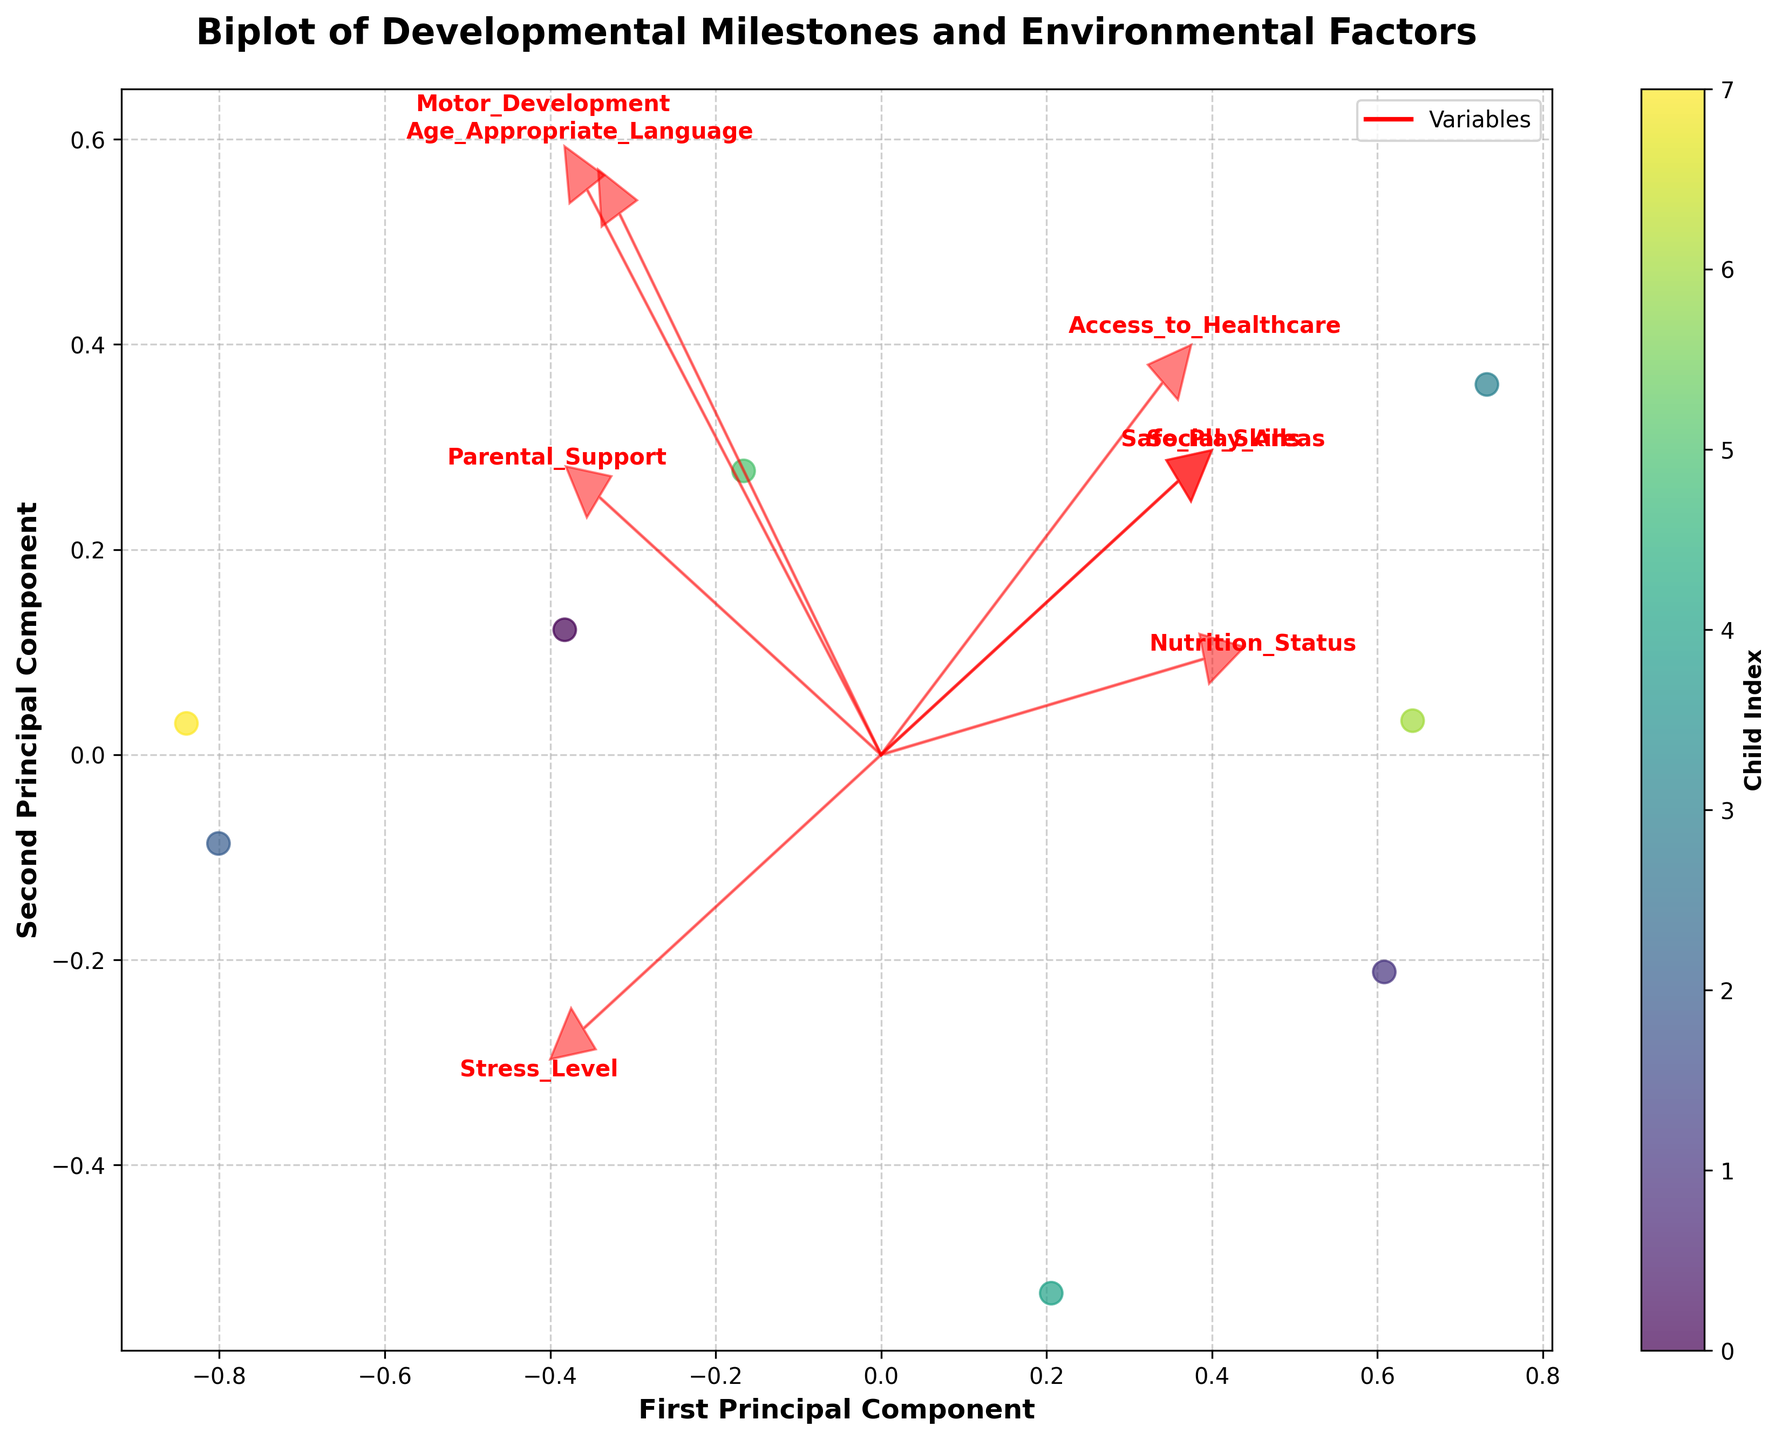What is the title of the plot? The title of the plot is usually displayed at the top of the figure. In this case, it reads 'Biplot of Developmental Milestones and Environmental Factors'.
Answer: Biplot of Developmental Milestones and Environmental Factors How many data points are represented in the plot? Each data point represents a child, and the scatter plot shows the positions of these points. Counting the individual points indicates there are 8 children.
Answer: 8 What do the red arrows in the plot represent? The red arrows represent the variables or features in the dataset, indicating the direction and strength of each variable's contribution to the principal components. Each arrow is labeled with the respective variable name.
Answer: Variables Which variables have the longest arrows, indicating the strongest contribution to the principal components? Longer arrows indicate stronger contributions. By examining the length of the arrows, 'Stress_Level' and 'Parental_Support' seem to have the longest arrows.
Answer: Stress_Level and Parental_Support On which axis is the ‘Access_to_Healthcare’ variable more aligned? The direction of the arrow for 'Access_to_Healthcare' suggests it is more aligned with the horizontal axis (First Principal Component) compared to the vertical axis (Second Principal Component).
Answer: First Principal Component Which child likely has the highest level of 'Age_Appropriate_Language'? The color bar helps identify the indices, and by checking the position of the points relative to the 'Age_Appropriate_Language' arrow, Child 3 appears to be the closest in the direction of the arrow.
Answer: Child 3 Which two children are most similar based on the principal components? Finding the points that are closest to each other in the scatter plot, Child 4 and Child 7 appear very close, indicating similar values in their principal components.
Answer: Child 4 and Child 7 What variable appears to be least correlated with 'Motor_Development'? Variables at approximately perpendicular angles to each other indicate lower correlation. 'Safe_Play_Areas' is nearly perpendicular to 'Motor_Development', indicating it is least correlated.
Answer: Safe_Play_Areas Which variable is highly correlated with the 'Second Principal Component'? The arrow that is mostly aligned with the vertical axis indicates high correlation with the Second Principal Component. 'Social_Skills' shows a strong alignment with the vertical (second) axis.
Answer: Social_Skills 